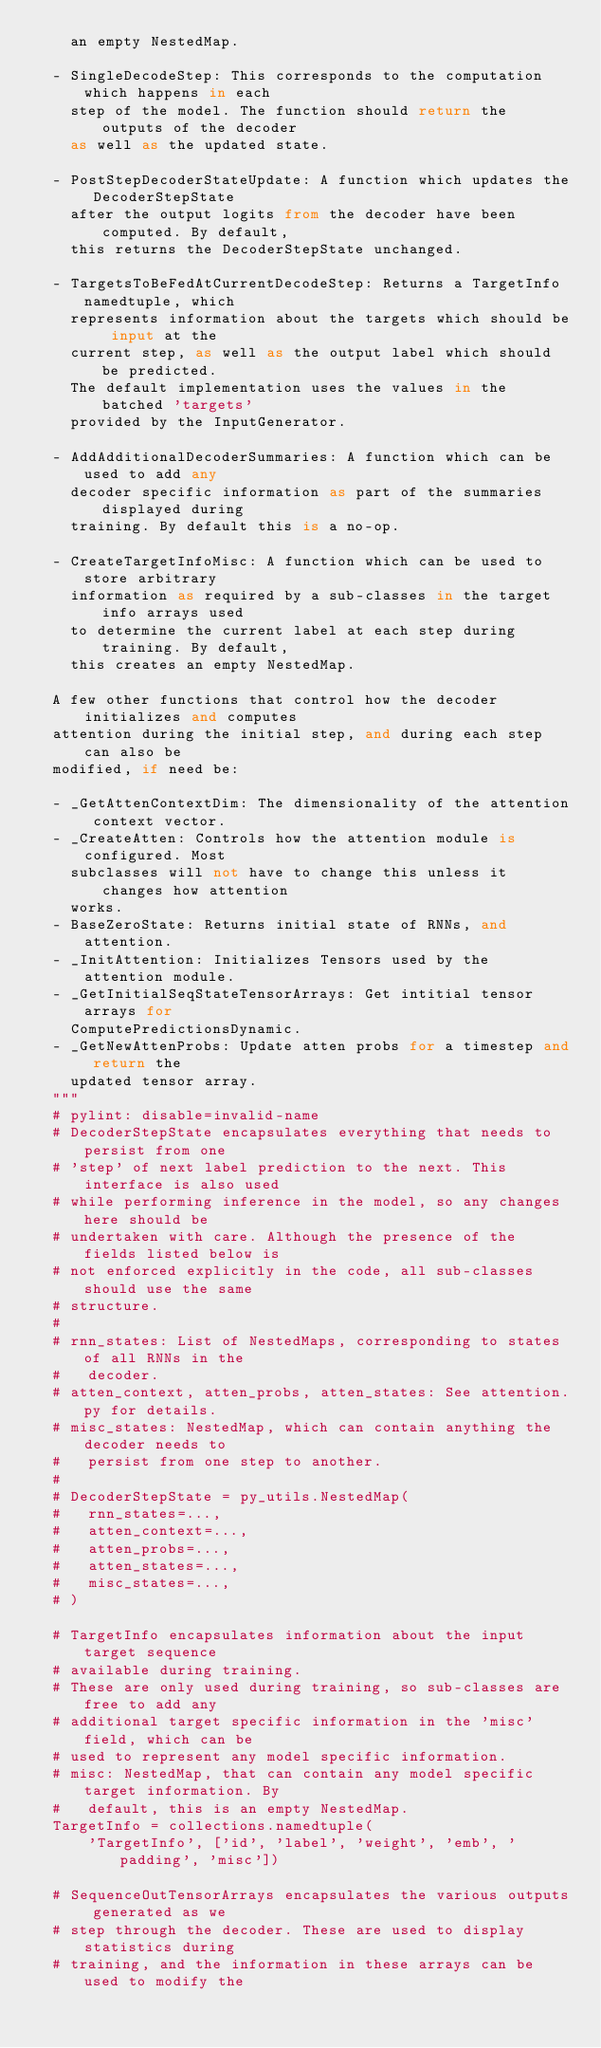<code> <loc_0><loc_0><loc_500><loc_500><_Python_>    an empty NestedMap.

  - SingleDecodeStep: This corresponds to the computation which happens in each
    step of the model. The function should return the outputs of the decoder
    as well as the updated state.

  - PostStepDecoderStateUpdate: A function which updates the DecoderStepState
    after the output logits from the decoder have been computed. By default,
    this returns the DecoderStepState unchanged.

  - TargetsToBeFedAtCurrentDecodeStep: Returns a TargetInfo namedtuple, which
    represents information about the targets which should be input at the
    current step, as well as the output label which should be predicted.
    The default implementation uses the values in the batched 'targets'
    provided by the InputGenerator.

  - AddAdditionalDecoderSummaries: A function which can be used to add any
    decoder specific information as part of the summaries displayed during
    training. By default this is a no-op.

  - CreateTargetInfoMisc: A function which can be used to store arbitrary
    information as required by a sub-classes in the target info arrays used
    to determine the current label at each step during training. By default,
    this creates an empty NestedMap.

  A few other functions that control how the decoder initializes and computes
  attention during the initial step, and during each step can also be
  modified, if need be:

  - _GetAttenContextDim: The dimensionality of the attention context vector.
  - _CreateAtten: Controls how the attention module is configured. Most
    subclasses will not have to change this unless it changes how attention
    works.
  - BaseZeroState: Returns initial state of RNNs, and attention.
  - _InitAttention: Initializes Tensors used by the attention module.
  - _GetInitialSeqStateTensorArrays: Get intitial tensor arrays for
    ComputePredictionsDynamic.
  - _GetNewAttenProbs: Update atten probs for a timestep and return the
    updated tensor array.
  """
  # pylint: disable=invalid-name
  # DecoderStepState encapsulates everything that needs to persist from one
  # 'step' of next label prediction to the next. This interface is also used
  # while performing inference in the model, so any changes here should be
  # undertaken with care. Although the presence of the fields listed below is
  # not enforced explicitly in the code, all sub-classes should use the same
  # structure.
  #
  # rnn_states: List of NestedMaps, corresponding to states of all RNNs in the
  #   decoder.
  # atten_context, atten_probs, atten_states: See attention.py for details.
  # misc_states: NestedMap, which can contain anything the decoder needs to
  #   persist from one step to another.
  #
  # DecoderStepState = py_utils.NestedMap(
  #   rnn_states=...,
  #   atten_context=...,
  #   atten_probs=...,
  #   atten_states=...,
  #   misc_states=...,
  # )

  # TargetInfo encapsulates information about the input target sequence
  # available during training.
  # These are only used during training, so sub-classes are free to add any
  # additional target specific information in the 'misc' field, which can be
  # used to represent any model specific information.
  # misc: NestedMap, that can contain any model specific target information. By
  #   default, this is an empty NestedMap.
  TargetInfo = collections.namedtuple(
      'TargetInfo', ['id', 'label', 'weight', 'emb', 'padding', 'misc'])

  # SequenceOutTensorArrays encapsulates the various outputs generated as we
  # step through the decoder. These are used to display statistics during
  # training, and the information in these arrays can be used to modify the</code> 